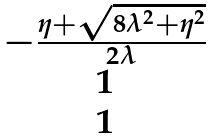<formula> <loc_0><loc_0><loc_500><loc_500>\begin{matrix} - \frac { \eta + \sqrt { 8 \lambda ^ { 2 } + \eta ^ { 2 } } } { 2 \lambda } \\ 1 \\ 1 \end{matrix}</formula> 